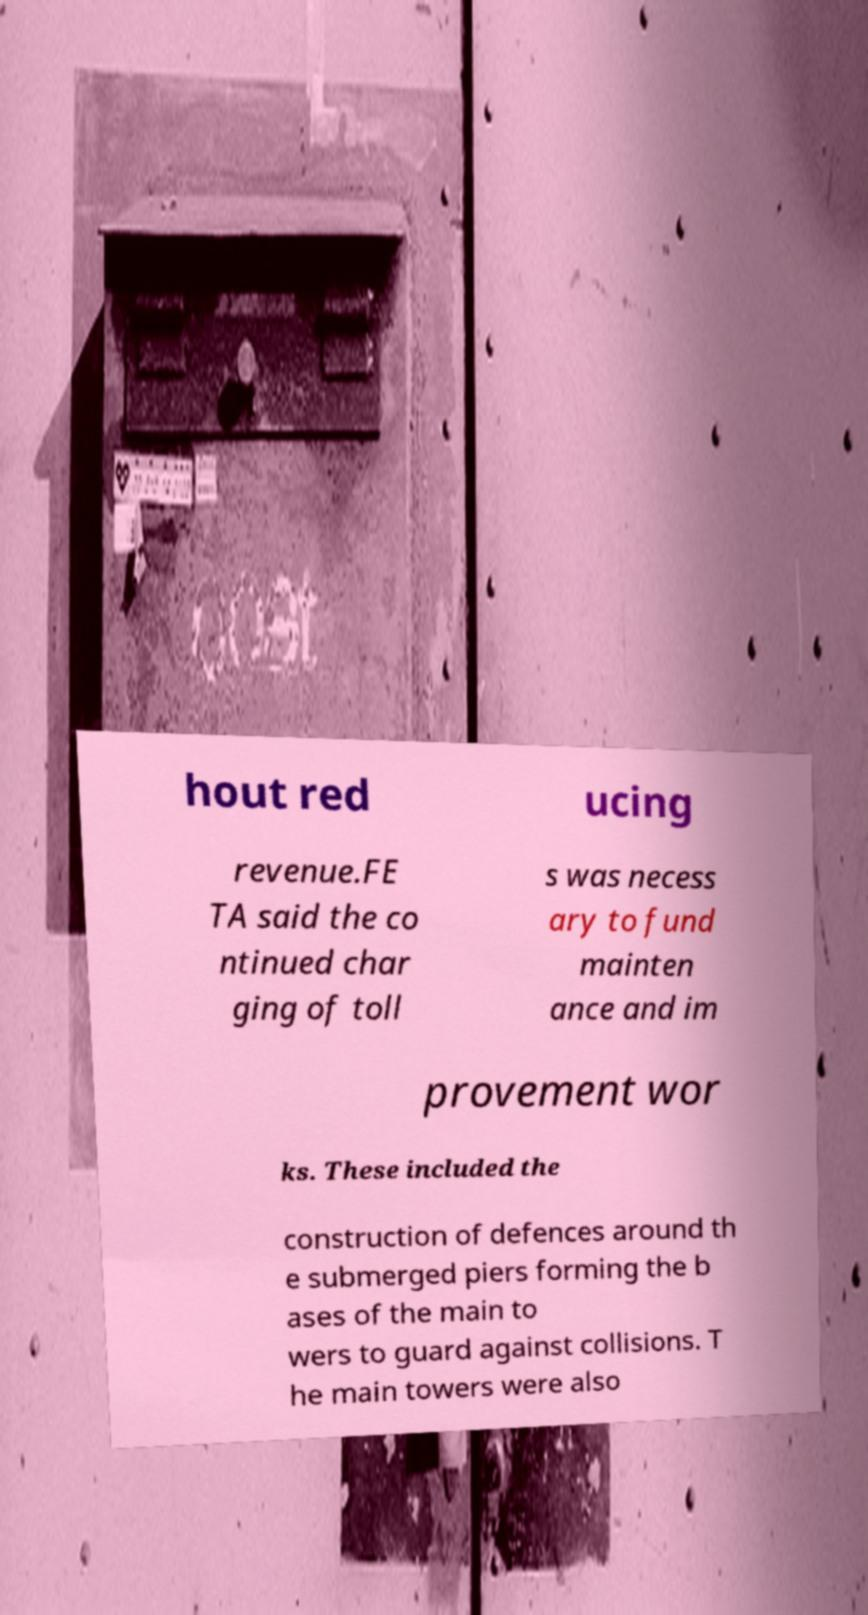Could you extract and type out the text from this image? hout red ucing revenue.FE TA said the co ntinued char ging of toll s was necess ary to fund mainten ance and im provement wor ks. These included the construction of defences around th e submerged piers forming the b ases of the main to wers to guard against collisions. T he main towers were also 